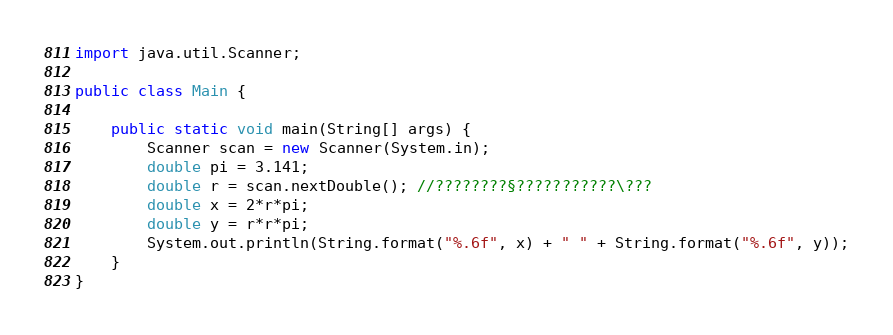<code> <loc_0><loc_0><loc_500><loc_500><_Java_>import java.util.Scanner;

public class Main {

	public static void main(String[] args) {
		Scanner scan = new Scanner(System.in);
		double pi = 3.141;
		double r = scan.nextDouble(); //????????§???????????\???
		double x = 2*r*pi;
		double y = r*r*pi;
		System.out.println(String.format("%.6f", x) + " " + String.format("%.6f", y));
	}
}</code> 